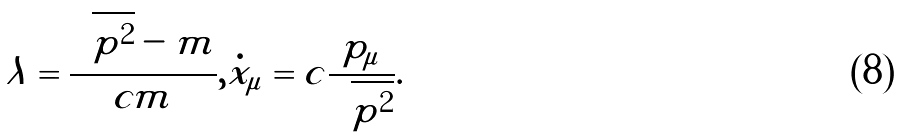<formula> <loc_0><loc_0><loc_500><loc_500>\lambda = \frac { \sqrt { \tilde { p } ^ { 2 } } - m } { c m } , \dot { x } _ { \mu } = c \frac { \tilde { p } _ { \mu } } { \sqrt { \tilde { p } ^ { 2 } } } .</formula> 